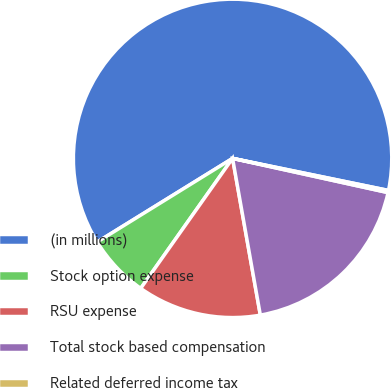Convert chart to OTSL. <chart><loc_0><loc_0><loc_500><loc_500><pie_chart><fcel>(in millions)<fcel>Stock option expense<fcel>RSU expense<fcel>Total stock based compensation<fcel>Related deferred income tax<nl><fcel>62.04%<fcel>6.4%<fcel>12.58%<fcel>18.76%<fcel>0.22%<nl></chart> 